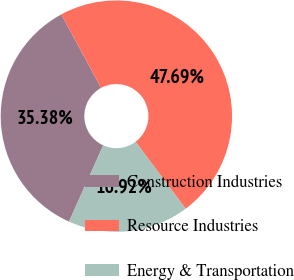<chart> <loc_0><loc_0><loc_500><loc_500><pie_chart><fcel>Construction Industries<fcel>Resource Industries<fcel>Energy & Transportation<nl><fcel>35.38%<fcel>47.69%<fcel>16.92%<nl></chart> 